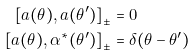Convert formula to latex. <formula><loc_0><loc_0><loc_500><loc_500>\left [ a ( \theta ) , a ( \theta ^ { \prime } ) \right ] _ { \pm } & = 0 \\ \left [ a ( \theta ) , \alpha ^ { \ast } ( \theta ^ { \prime } ) \right ] _ { \pm } & = \delta ( \theta - \theta ^ { \prime } )</formula> 